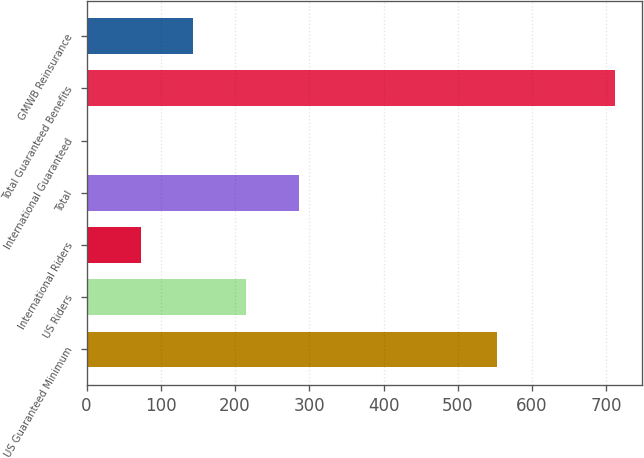<chart> <loc_0><loc_0><loc_500><loc_500><bar_chart><fcel>US Guaranteed Minimum<fcel>US Riders<fcel>International Riders<fcel>Total<fcel>International Guaranteed<fcel>Total Guaranteed Benefits<fcel>GMWB Reinsurance<nl><fcel>553<fcel>215<fcel>73<fcel>286<fcel>2<fcel>712<fcel>144<nl></chart> 